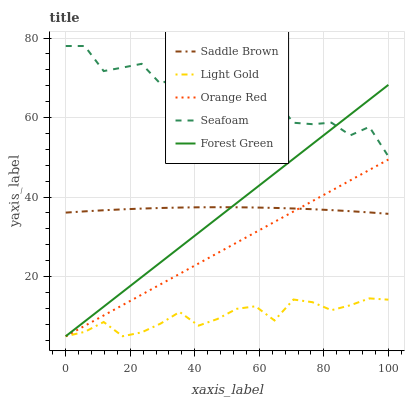Does Forest Green have the minimum area under the curve?
Answer yes or no. No. Does Forest Green have the maximum area under the curve?
Answer yes or no. No. Is Forest Green the smoothest?
Answer yes or no. No. Is Forest Green the roughest?
Answer yes or no. No. Does Saddle Brown have the lowest value?
Answer yes or no. No. Does Forest Green have the highest value?
Answer yes or no. No. Is Light Gold less than Saddle Brown?
Answer yes or no. Yes. Is Seafoam greater than Light Gold?
Answer yes or no. Yes. Does Light Gold intersect Saddle Brown?
Answer yes or no. No. 